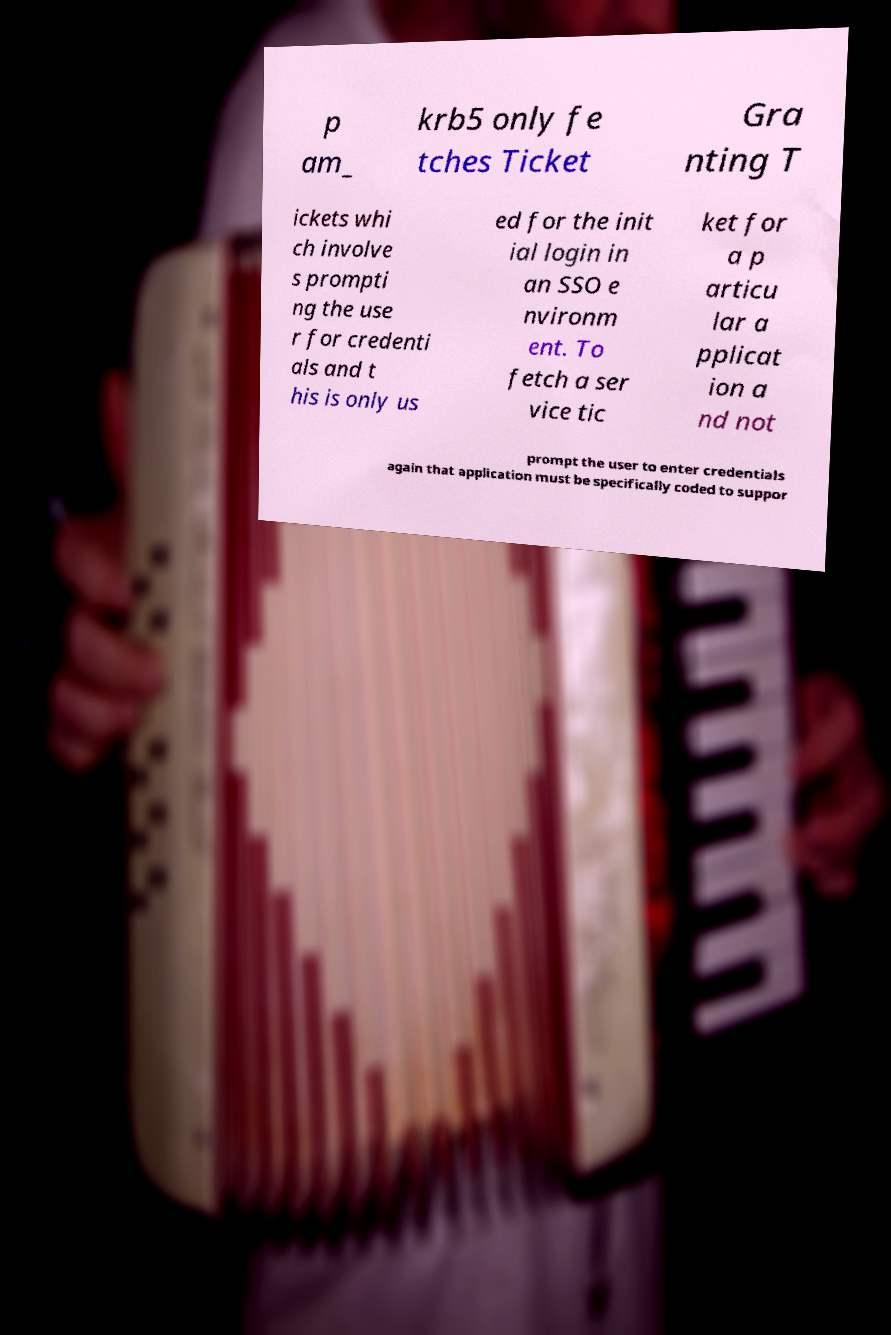For documentation purposes, I need the text within this image transcribed. Could you provide that? p am_ krb5 only fe tches Ticket Gra nting T ickets whi ch involve s prompti ng the use r for credenti als and t his is only us ed for the init ial login in an SSO e nvironm ent. To fetch a ser vice tic ket for a p articu lar a pplicat ion a nd not prompt the user to enter credentials again that application must be specifically coded to suppor 